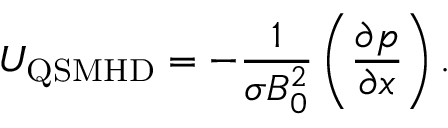<formula> <loc_0><loc_0><loc_500><loc_500>U _ { Q S M H D } = - \frac { 1 } { \sigma B _ { 0 } ^ { 2 } } \left ( \frac { \partial p } { \partial x } \right ) .</formula> 